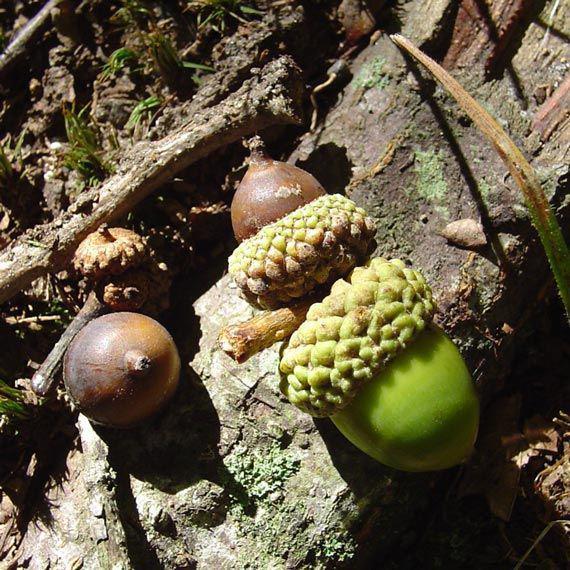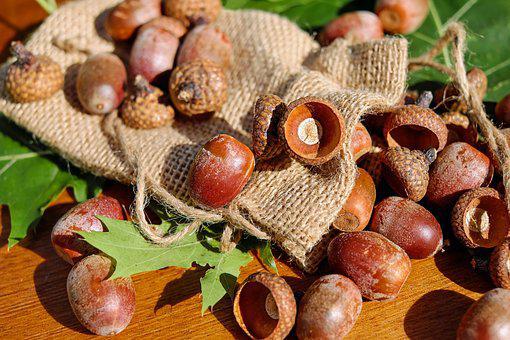The first image is the image on the left, the second image is the image on the right. For the images displayed, is the sentence "There are brown and green acorns." factually correct? Answer yes or no. Yes. The first image is the image on the left, the second image is the image on the right. Considering the images on both sides, is "The left image includes at least one large green acorn with its cap on next to smaller brown acorns." valid? Answer yes or no. Yes. 